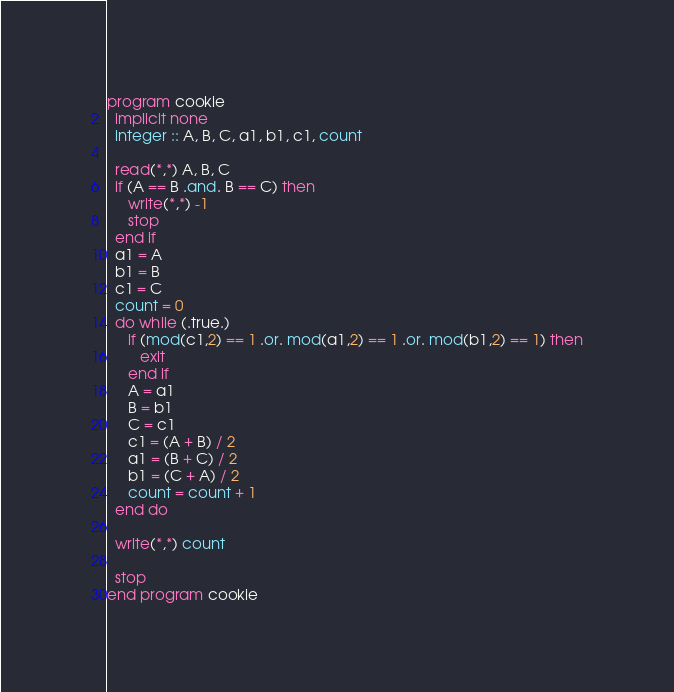Convert code to text. <code><loc_0><loc_0><loc_500><loc_500><_FORTRAN_>program cookie
  implicit none
  integer :: A, B, C, a1, b1, c1, count
  
  read(*,*) A, B, C
  if (A == B .and. B == C) then
     write(*,*) -1
     stop
  end if
  a1 = A
  b1 = B
  c1 = C
  count = 0
  do while (.true.)
     if (mod(c1,2) == 1 .or. mod(a1,2) == 1 .or. mod(b1,2) == 1) then
        exit
     end if
     A = a1
     B = b1
     C = c1
     c1 = (A + B) / 2
     a1 = (B + C) / 2
     b1 = (C + A) / 2
     count = count + 1
  end do

  write(*,*) count
  
  stop
end program cookie
</code> 